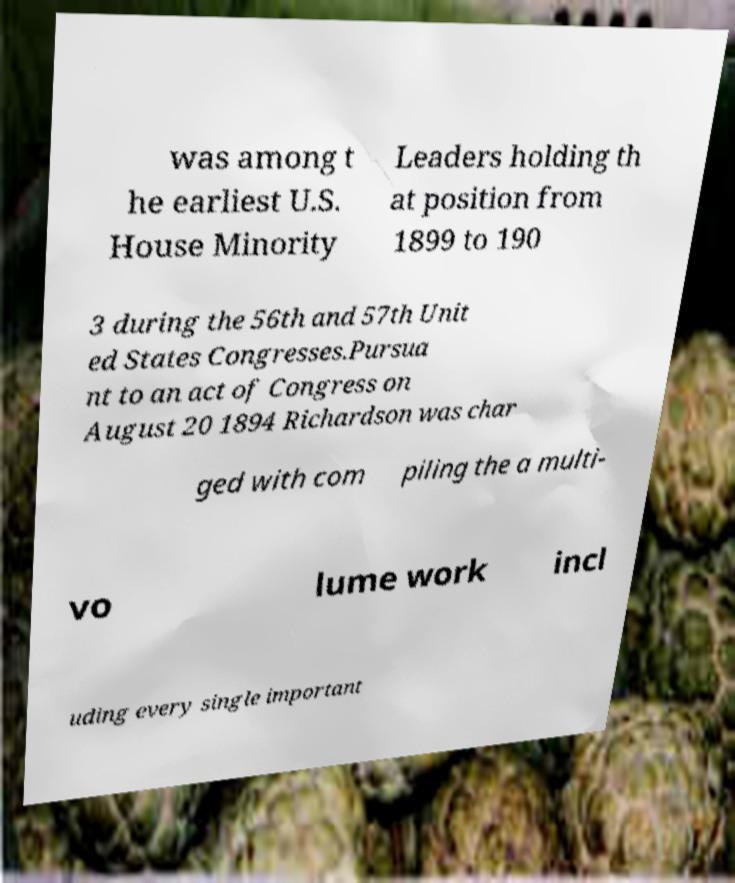Please read and relay the text visible in this image. What does it say? was among t he earliest U.S. House Minority Leaders holding th at position from 1899 to 190 3 during the 56th and 57th Unit ed States Congresses.Pursua nt to an act of Congress on August 20 1894 Richardson was char ged with com piling the a multi- vo lume work incl uding every single important 